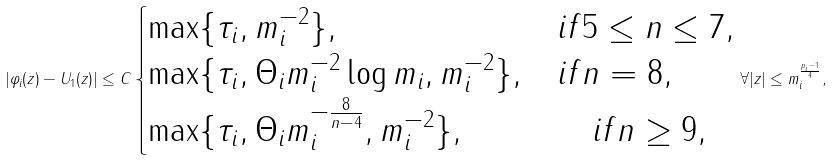<formula> <loc_0><loc_0><loc_500><loc_500>| \varphi _ { i } ( z ) - U _ { 1 } ( z ) | \leq C \begin{cases} \max \{ \tau _ { i } , m _ { i } ^ { - 2 } \} , & i f 5 \leq n \leq 7 , \\ \max \{ \tau _ { i } , \Theta _ { i } m _ { i } ^ { - 2 } \log m _ { i } , m _ { i } ^ { - 2 } \} , & i f n = 8 , \\ \max \{ \tau _ { i } , \Theta _ { i } m _ { i } ^ { - \frac { 8 } { n - 4 } } , m _ { i } ^ { - 2 } \} , & \quad i f n \geq 9 , \end{cases} \forall | z | \leq m _ { i } ^ { \frac { p _ { i } - 1 } { 4 } } ,</formula> 